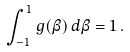<formula> <loc_0><loc_0><loc_500><loc_500>\int _ { - 1 } ^ { 1 } g ( \beta ) \, d \beta = 1 \, .</formula> 